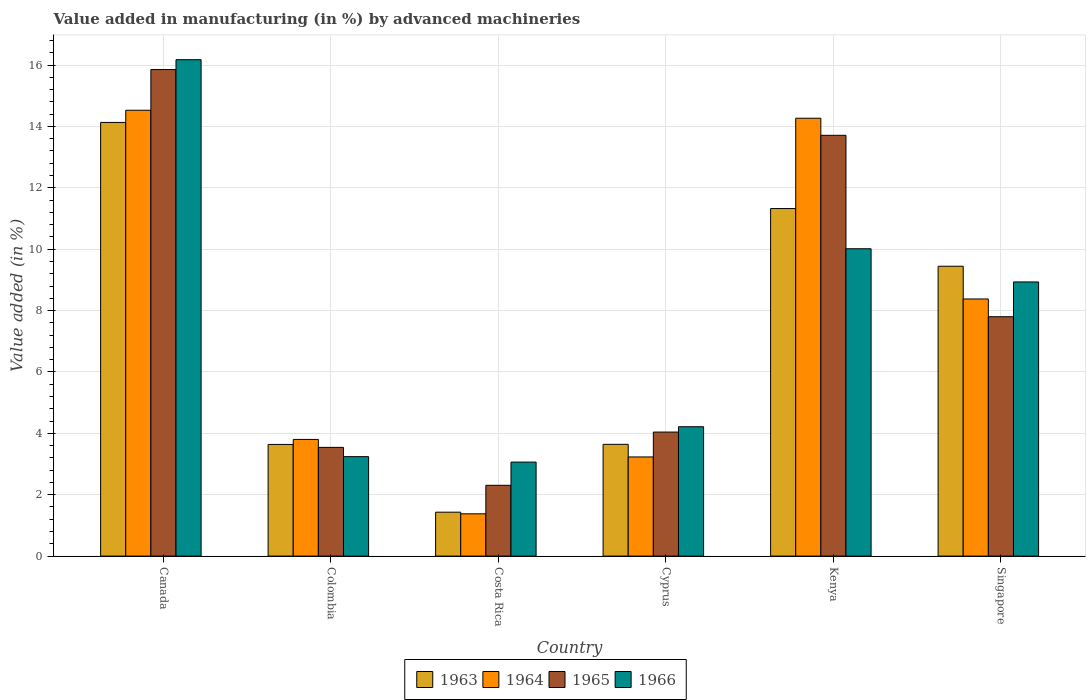How many groups of bars are there?
Your answer should be compact. 6. Are the number of bars per tick equal to the number of legend labels?
Offer a very short reply. Yes. How many bars are there on the 4th tick from the left?
Keep it short and to the point. 4. How many bars are there on the 3rd tick from the right?
Provide a short and direct response. 4. What is the percentage of value added in manufacturing by advanced machineries in 1963 in Colombia?
Your answer should be very brief. 3.64. Across all countries, what is the maximum percentage of value added in manufacturing by advanced machineries in 1965?
Provide a succinct answer. 15.85. Across all countries, what is the minimum percentage of value added in manufacturing by advanced machineries in 1966?
Your answer should be compact. 3.06. In which country was the percentage of value added in manufacturing by advanced machineries in 1964 maximum?
Your response must be concise. Canada. What is the total percentage of value added in manufacturing by advanced machineries in 1965 in the graph?
Give a very brief answer. 47.25. What is the difference between the percentage of value added in manufacturing by advanced machineries in 1963 in Colombia and that in Singapore?
Give a very brief answer. -5.81. What is the difference between the percentage of value added in manufacturing by advanced machineries in 1963 in Colombia and the percentage of value added in manufacturing by advanced machineries in 1966 in Costa Rica?
Your answer should be very brief. 0.57. What is the average percentage of value added in manufacturing by advanced machineries in 1966 per country?
Your answer should be compact. 7.61. What is the difference between the percentage of value added in manufacturing by advanced machineries of/in 1966 and percentage of value added in manufacturing by advanced machineries of/in 1965 in Singapore?
Ensure brevity in your answer.  1.13. In how many countries, is the percentage of value added in manufacturing by advanced machineries in 1963 greater than 6 %?
Provide a short and direct response. 3. What is the ratio of the percentage of value added in manufacturing by advanced machineries in 1964 in Canada to that in Cyprus?
Provide a short and direct response. 4.5. Is the difference between the percentage of value added in manufacturing by advanced machineries in 1966 in Canada and Costa Rica greater than the difference between the percentage of value added in manufacturing by advanced machineries in 1965 in Canada and Costa Rica?
Ensure brevity in your answer.  No. What is the difference between the highest and the second highest percentage of value added in manufacturing by advanced machineries in 1965?
Make the answer very short. -5.91. What is the difference between the highest and the lowest percentage of value added in manufacturing by advanced machineries in 1966?
Offer a very short reply. 13.11. In how many countries, is the percentage of value added in manufacturing by advanced machineries in 1963 greater than the average percentage of value added in manufacturing by advanced machineries in 1963 taken over all countries?
Provide a succinct answer. 3. Is the sum of the percentage of value added in manufacturing by advanced machineries in 1963 in Costa Rica and Kenya greater than the maximum percentage of value added in manufacturing by advanced machineries in 1966 across all countries?
Provide a short and direct response. No. What does the 3rd bar from the left in Cyprus represents?
Your response must be concise. 1965. How many bars are there?
Offer a terse response. 24. How many countries are there in the graph?
Provide a short and direct response. 6. Are the values on the major ticks of Y-axis written in scientific E-notation?
Provide a short and direct response. No. How many legend labels are there?
Make the answer very short. 4. How are the legend labels stacked?
Give a very brief answer. Horizontal. What is the title of the graph?
Make the answer very short. Value added in manufacturing (in %) by advanced machineries. Does "1989" appear as one of the legend labels in the graph?
Your answer should be very brief. No. What is the label or title of the X-axis?
Your response must be concise. Country. What is the label or title of the Y-axis?
Make the answer very short. Value added (in %). What is the Value added (in %) in 1963 in Canada?
Offer a very short reply. 14.13. What is the Value added (in %) in 1964 in Canada?
Your response must be concise. 14.53. What is the Value added (in %) of 1965 in Canada?
Make the answer very short. 15.85. What is the Value added (in %) in 1966 in Canada?
Offer a very short reply. 16.17. What is the Value added (in %) in 1963 in Colombia?
Your response must be concise. 3.64. What is the Value added (in %) of 1964 in Colombia?
Make the answer very short. 3.8. What is the Value added (in %) in 1965 in Colombia?
Give a very brief answer. 3.54. What is the Value added (in %) in 1966 in Colombia?
Offer a terse response. 3.24. What is the Value added (in %) of 1963 in Costa Rica?
Ensure brevity in your answer.  1.43. What is the Value added (in %) in 1964 in Costa Rica?
Give a very brief answer. 1.38. What is the Value added (in %) in 1965 in Costa Rica?
Offer a very short reply. 2.31. What is the Value added (in %) of 1966 in Costa Rica?
Keep it short and to the point. 3.06. What is the Value added (in %) of 1963 in Cyprus?
Offer a very short reply. 3.64. What is the Value added (in %) in 1964 in Cyprus?
Keep it short and to the point. 3.23. What is the Value added (in %) of 1965 in Cyprus?
Your answer should be very brief. 4.04. What is the Value added (in %) in 1966 in Cyprus?
Make the answer very short. 4.22. What is the Value added (in %) in 1963 in Kenya?
Provide a short and direct response. 11.32. What is the Value added (in %) of 1964 in Kenya?
Offer a very short reply. 14.27. What is the Value added (in %) of 1965 in Kenya?
Provide a succinct answer. 13.71. What is the Value added (in %) in 1966 in Kenya?
Ensure brevity in your answer.  10.01. What is the Value added (in %) in 1963 in Singapore?
Your response must be concise. 9.44. What is the Value added (in %) in 1964 in Singapore?
Give a very brief answer. 8.38. What is the Value added (in %) of 1965 in Singapore?
Offer a terse response. 7.8. What is the Value added (in %) in 1966 in Singapore?
Provide a succinct answer. 8.93. Across all countries, what is the maximum Value added (in %) in 1963?
Your answer should be very brief. 14.13. Across all countries, what is the maximum Value added (in %) of 1964?
Offer a terse response. 14.53. Across all countries, what is the maximum Value added (in %) in 1965?
Provide a succinct answer. 15.85. Across all countries, what is the maximum Value added (in %) in 1966?
Make the answer very short. 16.17. Across all countries, what is the minimum Value added (in %) in 1963?
Keep it short and to the point. 1.43. Across all countries, what is the minimum Value added (in %) of 1964?
Ensure brevity in your answer.  1.38. Across all countries, what is the minimum Value added (in %) of 1965?
Keep it short and to the point. 2.31. Across all countries, what is the minimum Value added (in %) of 1966?
Provide a short and direct response. 3.06. What is the total Value added (in %) in 1963 in the graph?
Make the answer very short. 43.61. What is the total Value added (in %) in 1964 in the graph?
Provide a short and direct response. 45.58. What is the total Value added (in %) in 1965 in the graph?
Keep it short and to the point. 47.25. What is the total Value added (in %) of 1966 in the graph?
Keep it short and to the point. 45.64. What is the difference between the Value added (in %) in 1963 in Canada and that in Colombia?
Keep it short and to the point. 10.49. What is the difference between the Value added (in %) in 1964 in Canada and that in Colombia?
Make the answer very short. 10.72. What is the difference between the Value added (in %) of 1965 in Canada and that in Colombia?
Keep it short and to the point. 12.31. What is the difference between the Value added (in %) in 1966 in Canada and that in Colombia?
Your response must be concise. 12.93. What is the difference between the Value added (in %) of 1963 in Canada and that in Costa Rica?
Offer a very short reply. 12.7. What is the difference between the Value added (in %) of 1964 in Canada and that in Costa Rica?
Give a very brief answer. 13.15. What is the difference between the Value added (in %) in 1965 in Canada and that in Costa Rica?
Provide a succinct answer. 13.55. What is the difference between the Value added (in %) in 1966 in Canada and that in Costa Rica?
Offer a terse response. 13.11. What is the difference between the Value added (in %) in 1963 in Canada and that in Cyprus?
Ensure brevity in your answer.  10.49. What is the difference between the Value added (in %) in 1964 in Canada and that in Cyprus?
Provide a succinct answer. 11.3. What is the difference between the Value added (in %) of 1965 in Canada and that in Cyprus?
Keep it short and to the point. 11.81. What is the difference between the Value added (in %) in 1966 in Canada and that in Cyprus?
Ensure brevity in your answer.  11.96. What is the difference between the Value added (in %) in 1963 in Canada and that in Kenya?
Provide a short and direct response. 2.81. What is the difference between the Value added (in %) of 1964 in Canada and that in Kenya?
Provide a succinct answer. 0.26. What is the difference between the Value added (in %) in 1965 in Canada and that in Kenya?
Your response must be concise. 2.14. What is the difference between the Value added (in %) in 1966 in Canada and that in Kenya?
Ensure brevity in your answer.  6.16. What is the difference between the Value added (in %) in 1963 in Canada and that in Singapore?
Your response must be concise. 4.69. What is the difference between the Value added (in %) in 1964 in Canada and that in Singapore?
Your answer should be compact. 6.15. What is the difference between the Value added (in %) of 1965 in Canada and that in Singapore?
Provide a succinct answer. 8.05. What is the difference between the Value added (in %) of 1966 in Canada and that in Singapore?
Offer a very short reply. 7.24. What is the difference between the Value added (in %) of 1963 in Colombia and that in Costa Rica?
Keep it short and to the point. 2.21. What is the difference between the Value added (in %) in 1964 in Colombia and that in Costa Rica?
Provide a succinct answer. 2.42. What is the difference between the Value added (in %) of 1965 in Colombia and that in Costa Rica?
Keep it short and to the point. 1.24. What is the difference between the Value added (in %) of 1966 in Colombia and that in Costa Rica?
Offer a very short reply. 0.18. What is the difference between the Value added (in %) of 1963 in Colombia and that in Cyprus?
Keep it short and to the point. -0. What is the difference between the Value added (in %) in 1964 in Colombia and that in Cyprus?
Keep it short and to the point. 0.57. What is the difference between the Value added (in %) in 1965 in Colombia and that in Cyprus?
Your answer should be very brief. -0.5. What is the difference between the Value added (in %) of 1966 in Colombia and that in Cyprus?
Your answer should be compact. -0.97. What is the difference between the Value added (in %) of 1963 in Colombia and that in Kenya?
Keep it short and to the point. -7.69. What is the difference between the Value added (in %) in 1964 in Colombia and that in Kenya?
Make the answer very short. -10.47. What is the difference between the Value added (in %) of 1965 in Colombia and that in Kenya?
Offer a very short reply. -10.17. What is the difference between the Value added (in %) in 1966 in Colombia and that in Kenya?
Provide a succinct answer. -6.77. What is the difference between the Value added (in %) of 1963 in Colombia and that in Singapore?
Make the answer very short. -5.81. What is the difference between the Value added (in %) of 1964 in Colombia and that in Singapore?
Make the answer very short. -4.58. What is the difference between the Value added (in %) in 1965 in Colombia and that in Singapore?
Your response must be concise. -4.26. What is the difference between the Value added (in %) in 1966 in Colombia and that in Singapore?
Give a very brief answer. -5.69. What is the difference between the Value added (in %) of 1963 in Costa Rica and that in Cyprus?
Provide a short and direct response. -2.21. What is the difference between the Value added (in %) in 1964 in Costa Rica and that in Cyprus?
Give a very brief answer. -1.85. What is the difference between the Value added (in %) in 1965 in Costa Rica and that in Cyprus?
Keep it short and to the point. -1.73. What is the difference between the Value added (in %) of 1966 in Costa Rica and that in Cyprus?
Your answer should be compact. -1.15. What is the difference between the Value added (in %) of 1963 in Costa Rica and that in Kenya?
Your answer should be compact. -9.89. What is the difference between the Value added (in %) of 1964 in Costa Rica and that in Kenya?
Keep it short and to the point. -12.89. What is the difference between the Value added (in %) of 1965 in Costa Rica and that in Kenya?
Your response must be concise. -11.4. What is the difference between the Value added (in %) of 1966 in Costa Rica and that in Kenya?
Make the answer very short. -6.95. What is the difference between the Value added (in %) of 1963 in Costa Rica and that in Singapore?
Give a very brief answer. -8.01. What is the difference between the Value added (in %) of 1964 in Costa Rica and that in Singapore?
Your response must be concise. -7. What is the difference between the Value added (in %) in 1965 in Costa Rica and that in Singapore?
Make the answer very short. -5.49. What is the difference between the Value added (in %) in 1966 in Costa Rica and that in Singapore?
Make the answer very short. -5.87. What is the difference between the Value added (in %) of 1963 in Cyprus and that in Kenya?
Your answer should be very brief. -7.68. What is the difference between the Value added (in %) in 1964 in Cyprus and that in Kenya?
Give a very brief answer. -11.04. What is the difference between the Value added (in %) of 1965 in Cyprus and that in Kenya?
Your response must be concise. -9.67. What is the difference between the Value added (in %) in 1966 in Cyprus and that in Kenya?
Offer a terse response. -5.8. What is the difference between the Value added (in %) in 1963 in Cyprus and that in Singapore?
Make the answer very short. -5.8. What is the difference between the Value added (in %) in 1964 in Cyprus and that in Singapore?
Keep it short and to the point. -5.15. What is the difference between the Value added (in %) of 1965 in Cyprus and that in Singapore?
Your response must be concise. -3.76. What is the difference between the Value added (in %) of 1966 in Cyprus and that in Singapore?
Your response must be concise. -4.72. What is the difference between the Value added (in %) of 1963 in Kenya and that in Singapore?
Your response must be concise. 1.88. What is the difference between the Value added (in %) in 1964 in Kenya and that in Singapore?
Give a very brief answer. 5.89. What is the difference between the Value added (in %) of 1965 in Kenya and that in Singapore?
Your answer should be compact. 5.91. What is the difference between the Value added (in %) in 1966 in Kenya and that in Singapore?
Provide a short and direct response. 1.08. What is the difference between the Value added (in %) of 1963 in Canada and the Value added (in %) of 1964 in Colombia?
Your answer should be very brief. 10.33. What is the difference between the Value added (in %) of 1963 in Canada and the Value added (in %) of 1965 in Colombia?
Give a very brief answer. 10.59. What is the difference between the Value added (in %) of 1963 in Canada and the Value added (in %) of 1966 in Colombia?
Offer a very short reply. 10.89. What is the difference between the Value added (in %) of 1964 in Canada and the Value added (in %) of 1965 in Colombia?
Your answer should be compact. 10.98. What is the difference between the Value added (in %) in 1964 in Canada and the Value added (in %) in 1966 in Colombia?
Ensure brevity in your answer.  11.29. What is the difference between the Value added (in %) of 1965 in Canada and the Value added (in %) of 1966 in Colombia?
Offer a very short reply. 12.61. What is the difference between the Value added (in %) in 1963 in Canada and the Value added (in %) in 1964 in Costa Rica?
Provide a succinct answer. 12.75. What is the difference between the Value added (in %) of 1963 in Canada and the Value added (in %) of 1965 in Costa Rica?
Provide a short and direct response. 11.82. What is the difference between the Value added (in %) in 1963 in Canada and the Value added (in %) in 1966 in Costa Rica?
Your answer should be compact. 11.07. What is the difference between the Value added (in %) in 1964 in Canada and the Value added (in %) in 1965 in Costa Rica?
Your response must be concise. 12.22. What is the difference between the Value added (in %) of 1964 in Canada and the Value added (in %) of 1966 in Costa Rica?
Provide a short and direct response. 11.46. What is the difference between the Value added (in %) of 1965 in Canada and the Value added (in %) of 1966 in Costa Rica?
Provide a succinct answer. 12.79. What is the difference between the Value added (in %) in 1963 in Canada and the Value added (in %) in 1964 in Cyprus?
Make the answer very short. 10.9. What is the difference between the Value added (in %) in 1963 in Canada and the Value added (in %) in 1965 in Cyprus?
Keep it short and to the point. 10.09. What is the difference between the Value added (in %) in 1963 in Canada and the Value added (in %) in 1966 in Cyprus?
Ensure brevity in your answer.  9.92. What is the difference between the Value added (in %) in 1964 in Canada and the Value added (in %) in 1965 in Cyprus?
Give a very brief answer. 10.49. What is the difference between the Value added (in %) in 1964 in Canada and the Value added (in %) in 1966 in Cyprus?
Provide a succinct answer. 10.31. What is the difference between the Value added (in %) in 1965 in Canada and the Value added (in %) in 1966 in Cyprus?
Your answer should be compact. 11.64. What is the difference between the Value added (in %) in 1963 in Canada and the Value added (in %) in 1964 in Kenya?
Provide a short and direct response. -0.14. What is the difference between the Value added (in %) of 1963 in Canada and the Value added (in %) of 1965 in Kenya?
Give a very brief answer. 0.42. What is the difference between the Value added (in %) in 1963 in Canada and the Value added (in %) in 1966 in Kenya?
Provide a short and direct response. 4.12. What is the difference between the Value added (in %) of 1964 in Canada and the Value added (in %) of 1965 in Kenya?
Provide a succinct answer. 0.82. What is the difference between the Value added (in %) of 1964 in Canada and the Value added (in %) of 1966 in Kenya?
Your response must be concise. 4.51. What is the difference between the Value added (in %) in 1965 in Canada and the Value added (in %) in 1966 in Kenya?
Ensure brevity in your answer.  5.84. What is the difference between the Value added (in %) of 1963 in Canada and the Value added (in %) of 1964 in Singapore?
Make the answer very short. 5.75. What is the difference between the Value added (in %) in 1963 in Canada and the Value added (in %) in 1965 in Singapore?
Make the answer very short. 6.33. What is the difference between the Value added (in %) in 1963 in Canada and the Value added (in %) in 1966 in Singapore?
Your answer should be very brief. 5.2. What is the difference between the Value added (in %) in 1964 in Canada and the Value added (in %) in 1965 in Singapore?
Ensure brevity in your answer.  6.73. What is the difference between the Value added (in %) of 1964 in Canada and the Value added (in %) of 1966 in Singapore?
Give a very brief answer. 5.59. What is the difference between the Value added (in %) of 1965 in Canada and the Value added (in %) of 1966 in Singapore?
Offer a very short reply. 6.92. What is the difference between the Value added (in %) in 1963 in Colombia and the Value added (in %) in 1964 in Costa Rica?
Your answer should be very brief. 2.26. What is the difference between the Value added (in %) in 1963 in Colombia and the Value added (in %) in 1965 in Costa Rica?
Your answer should be very brief. 1.33. What is the difference between the Value added (in %) in 1963 in Colombia and the Value added (in %) in 1966 in Costa Rica?
Offer a very short reply. 0.57. What is the difference between the Value added (in %) in 1964 in Colombia and the Value added (in %) in 1965 in Costa Rica?
Provide a succinct answer. 1.49. What is the difference between the Value added (in %) of 1964 in Colombia and the Value added (in %) of 1966 in Costa Rica?
Offer a terse response. 0.74. What is the difference between the Value added (in %) of 1965 in Colombia and the Value added (in %) of 1966 in Costa Rica?
Provide a succinct answer. 0.48. What is the difference between the Value added (in %) of 1963 in Colombia and the Value added (in %) of 1964 in Cyprus?
Provide a succinct answer. 0.41. What is the difference between the Value added (in %) of 1963 in Colombia and the Value added (in %) of 1965 in Cyprus?
Provide a short and direct response. -0.4. What is the difference between the Value added (in %) in 1963 in Colombia and the Value added (in %) in 1966 in Cyprus?
Keep it short and to the point. -0.58. What is the difference between the Value added (in %) of 1964 in Colombia and the Value added (in %) of 1965 in Cyprus?
Provide a short and direct response. -0.24. What is the difference between the Value added (in %) of 1964 in Colombia and the Value added (in %) of 1966 in Cyprus?
Your response must be concise. -0.41. What is the difference between the Value added (in %) in 1965 in Colombia and the Value added (in %) in 1966 in Cyprus?
Keep it short and to the point. -0.67. What is the difference between the Value added (in %) in 1963 in Colombia and the Value added (in %) in 1964 in Kenya?
Ensure brevity in your answer.  -10.63. What is the difference between the Value added (in %) in 1963 in Colombia and the Value added (in %) in 1965 in Kenya?
Offer a very short reply. -10.07. What is the difference between the Value added (in %) in 1963 in Colombia and the Value added (in %) in 1966 in Kenya?
Ensure brevity in your answer.  -6.38. What is the difference between the Value added (in %) of 1964 in Colombia and the Value added (in %) of 1965 in Kenya?
Your answer should be very brief. -9.91. What is the difference between the Value added (in %) of 1964 in Colombia and the Value added (in %) of 1966 in Kenya?
Provide a short and direct response. -6.21. What is the difference between the Value added (in %) in 1965 in Colombia and the Value added (in %) in 1966 in Kenya?
Your response must be concise. -6.47. What is the difference between the Value added (in %) of 1963 in Colombia and the Value added (in %) of 1964 in Singapore?
Provide a succinct answer. -4.74. What is the difference between the Value added (in %) of 1963 in Colombia and the Value added (in %) of 1965 in Singapore?
Offer a very short reply. -4.16. What is the difference between the Value added (in %) in 1963 in Colombia and the Value added (in %) in 1966 in Singapore?
Give a very brief answer. -5.29. What is the difference between the Value added (in %) of 1964 in Colombia and the Value added (in %) of 1965 in Singapore?
Your answer should be very brief. -4. What is the difference between the Value added (in %) in 1964 in Colombia and the Value added (in %) in 1966 in Singapore?
Your response must be concise. -5.13. What is the difference between the Value added (in %) in 1965 in Colombia and the Value added (in %) in 1966 in Singapore?
Offer a terse response. -5.39. What is the difference between the Value added (in %) of 1963 in Costa Rica and the Value added (in %) of 1964 in Cyprus?
Ensure brevity in your answer.  -1.8. What is the difference between the Value added (in %) in 1963 in Costa Rica and the Value added (in %) in 1965 in Cyprus?
Offer a terse response. -2.61. What is the difference between the Value added (in %) of 1963 in Costa Rica and the Value added (in %) of 1966 in Cyprus?
Your answer should be compact. -2.78. What is the difference between the Value added (in %) in 1964 in Costa Rica and the Value added (in %) in 1965 in Cyprus?
Give a very brief answer. -2.66. What is the difference between the Value added (in %) of 1964 in Costa Rica and the Value added (in %) of 1966 in Cyprus?
Make the answer very short. -2.84. What is the difference between the Value added (in %) of 1965 in Costa Rica and the Value added (in %) of 1966 in Cyprus?
Provide a succinct answer. -1.91. What is the difference between the Value added (in %) in 1963 in Costa Rica and the Value added (in %) in 1964 in Kenya?
Make the answer very short. -12.84. What is the difference between the Value added (in %) in 1963 in Costa Rica and the Value added (in %) in 1965 in Kenya?
Provide a succinct answer. -12.28. What is the difference between the Value added (in %) in 1963 in Costa Rica and the Value added (in %) in 1966 in Kenya?
Your answer should be compact. -8.58. What is the difference between the Value added (in %) in 1964 in Costa Rica and the Value added (in %) in 1965 in Kenya?
Offer a terse response. -12.33. What is the difference between the Value added (in %) of 1964 in Costa Rica and the Value added (in %) of 1966 in Kenya?
Your response must be concise. -8.64. What is the difference between the Value added (in %) of 1965 in Costa Rica and the Value added (in %) of 1966 in Kenya?
Your answer should be compact. -7.71. What is the difference between the Value added (in %) of 1963 in Costa Rica and the Value added (in %) of 1964 in Singapore?
Provide a short and direct response. -6.95. What is the difference between the Value added (in %) in 1963 in Costa Rica and the Value added (in %) in 1965 in Singapore?
Ensure brevity in your answer.  -6.37. What is the difference between the Value added (in %) of 1963 in Costa Rica and the Value added (in %) of 1966 in Singapore?
Your answer should be very brief. -7.5. What is the difference between the Value added (in %) in 1964 in Costa Rica and the Value added (in %) in 1965 in Singapore?
Give a very brief answer. -6.42. What is the difference between the Value added (in %) of 1964 in Costa Rica and the Value added (in %) of 1966 in Singapore?
Give a very brief answer. -7.55. What is the difference between the Value added (in %) in 1965 in Costa Rica and the Value added (in %) in 1966 in Singapore?
Ensure brevity in your answer.  -6.63. What is the difference between the Value added (in %) of 1963 in Cyprus and the Value added (in %) of 1964 in Kenya?
Offer a very short reply. -10.63. What is the difference between the Value added (in %) in 1963 in Cyprus and the Value added (in %) in 1965 in Kenya?
Offer a terse response. -10.07. What is the difference between the Value added (in %) of 1963 in Cyprus and the Value added (in %) of 1966 in Kenya?
Your answer should be very brief. -6.37. What is the difference between the Value added (in %) of 1964 in Cyprus and the Value added (in %) of 1965 in Kenya?
Your answer should be very brief. -10.48. What is the difference between the Value added (in %) of 1964 in Cyprus and the Value added (in %) of 1966 in Kenya?
Ensure brevity in your answer.  -6.78. What is the difference between the Value added (in %) of 1965 in Cyprus and the Value added (in %) of 1966 in Kenya?
Your answer should be compact. -5.97. What is the difference between the Value added (in %) of 1963 in Cyprus and the Value added (in %) of 1964 in Singapore?
Keep it short and to the point. -4.74. What is the difference between the Value added (in %) in 1963 in Cyprus and the Value added (in %) in 1965 in Singapore?
Provide a short and direct response. -4.16. What is the difference between the Value added (in %) in 1963 in Cyprus and the Value added (in %) in 1966 in Singapore?
Make the answer very short. -5.29. What is the difference between the Value added (in %) in 1964 in Cyprus and the Value added (in %) in 1965 in Singapore?
Provide a succinct answer. -4.57. What is the difference between the Value added (in %) of 1964 in Cyprus and the Value added (in %) of 1966 in Singapore?
Provide a succinct answer. -5.7. What is the difference between the Value added (in %) of 1965 in Cyprus and the Value added (in %) of 1966 in Singapore?
Make the answer very short. -4.89. What is the difference between the Value added (in %) in 1963 in Kenya and the Value added (in %) in 1964 in Singapore?
Your answer should be compact. 2.95. What is the difference between the Value added (in %) of 1963 in Kenya and the Value added (in %) of 1965 in Singapore?
Your answer should be very brief. 3.52. What is the difference between the Value added (in %) of 1963 in Kenya and the Value added (in %) of 1966 in Singapore?
Your answer should be compact. 2.39. What is the difference between the Value added (in %) of 1964 in Kenya and the Value added (in %) of 1965 in Singapore?
Provide a short and direct response. 6.47. What is the difference between the Value added (in %) in 1964 in Kenya and the Value added (in %) in 1966 in Singapore?
Keep it short and to the point. 5.33. What is the difference between the Value added (in %) in 1965 in Kenya and the Value added (in %) in 1966 in Singapore?
Keep it short and to the point. 4.78. What is the average Value added (in %) in 1963 per country?
Provide a short and direct response. 7.27. What is the average Value added (in %) in 1964 per country?
Offer a terse response. 7.6. What is the average Value added (in %) of 1965 per country?
Make the answer very short. 7.88. What is the average Value added (in %) of 1966 per country?
Provide a succinct answer. 7.61. What is the difference between the Value added (in %) of 1963 and Value added (in %) of 1964 in Canada?
Provide a short and direct response. -0.4. What is the difference between the Value added (in %) of 1963 and Value added (in %) of 1965 in Canada?
Ensure brevity in your answer.  -1.72. What is the difference between the Value added (in %) in 1963 and Value added (in %) in 1966 in Canada?
Provide a short and direct response. -2.04. What is the difference between the Value added (in %) in 1964 and Value added (in %) in 1965 in Canada?
Offer a terse response. -1.33. What is the difference between the Value added (in %) of 1964 and Value added (in %) of 1966 in Canada?
Provide a succinct answer. -1.65. What is the difference between the Value added (in %) in 1965 and Value added (in %) in 1966 in Canada?
Give a very brief answer. -0.32. What is the difference between the Value added (in %) in 1963 and Value added (in %) in 1964 in Colombia?
Give a very brief answer. -0.16. What is the difference between the Value added (in %) of 1963 and Value added (in %) of 1965 in Colombia?
Your response must be concise. 0.1. What is the difference between the Value added (in %) of 1963 and Value added (in %) of 1966 in Colombia?
Ensure brevity in your answer.  0.4. What is the difference between the Value added (in %) in 1964 and Value added (in %) in 1965 in Colombia?
Ensure brevity in your answer.  0.26. What is the difference between the Value added (in %) in 1964 and Value added (in %) in 1966 in Colombia?
Your answer should be very brief. 0.56. What is the difference between the Value added (in %) in 1965 and Value added (in %) in 1966 in Colombia?
Your answer should be very brief. 0.3. What is the difference between the Value added (in %) of 1963 and Value added (in %) of 1964 in Costa Rica?
Give a very brief answer. 0.05. What is the difference between the Value added (in %) in 1963 and Value added (in %) in 1965 in Costa Rica?
Your response must be concise. -0.88. What is the difference between the Value added (in %) in 1963 and Value added (in %) in 1966 in Costa Rica?
Ensure brevity in your answer.  -1.63. What is the difference between the Value added (in %) of 1964 and Value added (in %) of 1965 in Costa Rica?
Your response must be concise. -0.93. What is the difference between the Value added (in %) of 1964 and Value added (in %) of 1966 in Costa Rica?
Keep it short and to the point. -1.69. What is the difference between the Value added (in %) in 1965 and Value added (in %) in 1966 in Costa Rica?
Keep it short and to the point. -0.76. What is the difference between the Value added (in %) of 1963 and Value added (in %) of 1964 in Cyprus?
Give a very brief answer. 0.41. What is the difference between the Value added (in %) in 1963 and Value added (in %) in 1965 in Cyprus?
Provide a succinct answer. -0.4. What is the difference between the Value added (in %) in 1963 and Value added (in %) in 1966 in Cyprus?
Keep it short and to the point. -0.57. What is the difference between the Value added (in %) in 1964 and Value added (in %) in 1965 in Cyprus?
Your response must be concise. -0.81. What is the difference between the Value added (in %) of 1964 and Value added (in %) of 1966 in Cyprus?
Your answer should be compact. -0.98. What is the difference between the Value added (in %) in 1965 and Value added (in %) in 1966 in Cyprus?
Make the answer very short. -0.17. What is the difference between the Value added (in %) in 1963 and Value added (in %) in 1964 in Kenya?
Keep it short and to the point. -2.94. What is the difference between the Value added (in %) of 1963 and Value added (in %) of 1965 in Kenya?
Provide a short and direct response. -2.39. What is the difference between the Value added (in %) in 1963 and Value added (in %) in 1966 in Kenya?
Offer a terse response. 1.31. What is the difference between the Value added (in %) of 1964 and Value added (in %) of 1965 in Kenya?
Offer a very short reply. 0.56. What is the difference between the Value added (in %) in 1964 and Value added (in %) in 1966 in Kenya?
Provide a short and direct response. 4.25. What is the difference between the Value added (in %) of 1965 and Value added (in %) of 1966 in Kenya?
Your answer should be very brief. 3.7. What is the difference between the Value added (in %) of 1963 and Value added (in %) of 1964 in Singapore?
Provide a short and direct response. 1.07. What is the difference between the Value added (in %) of 1963 and Value added (in %) of 1965 in Singapore?
Your response must be concise. 1.64. What is the difference between the Value added (in %) of 1963 and Value added (in %) of 1966 in Singapore?
Your answer should be very brief. 0.51. What is the difference between the Value added (in %) in 1964 and Value added (in %) in 1965 in Singapore?
Keep it short and to the point. 0.58. What is the difference between the Value added (in %) of 1964 and Value added (in %) of 1966 in Singapore?
Ensure brevity in your answer.  -0.55. What is the difference between the Value added (in %) of 1965 and Value added (in %) of 1966 in Singapore?
Offer a terse response. -1.13. What is the ratio of the Value added (in %) in 1963 in Canada to that in Colombia?
Keep it short and to the point. 3.88. What is the ratio of the Value added (in %) in 1964 in Canada to that in Colombia?
Your answer should be very brief. 3.82. What is the ratio of the Value added (in %) in 1965 in Canada to that in Colombia?
Make the answer very short. 4.48. What is the ratio of the Value added (in %) in 1966 in Canada to that in Colombia?
Provide a succinct answer. 4.99. What is the ratio of the Value added (in %) in 1963 in Canada to that in Costa Rica?
Offer a very short reply. 9.87. What is the ratio of the Value added (in %) in 1964 in Canada to that in Costa Rica?
Your response must be concise. 10.54. What is the ratio of the Value added (in %) in 1965 in Canada to that in Costa Rica?
Your answer should be very brief. 6.87. What is the ratio of the Value added (in %) of 1966 in Canada to that in Costa Rica?
Your answer should be very brief. 5.28. What is the ratio of the Value added (in %) of 1963 in Canada to that in Cyprus?
Your response must be concise. 3.88. What is the ratio of the Value added (in %) in 1964 in Canada to that in Cyprus?
Provide a short and direct response. 4.5. What is the ratio of the Value added (in %) of 1965 in Canada to that in Cyprus?
Your answer should be very brief. 3.92. What is the ratio of the Value added (in %) in 1966 in Canada to that in Cyprus?
Offer a terse response. 3.84. What is the ratio of the Value added (in %) in 1963 in Canada to that in Kenya?
Make the answer very short. 1.25. What is the ratio of the Value added (in %) of 1964 in Canada to that in Kenya?
Give a very brief answer. 1.02. What is the ratio of the Value added (in %) of 1965 in Canada to that in Kenya?
Give a very brief answer. 1.16. What is the ratio of the Value added (in %) in 1966 in Canada to that in Kenya?
Provide a succinct answer. 1.62. What is the ratio of the Value added (in %) in 1963 in Canada to that in Singapore?
Provide a short and direct response. 1.5. What is the ratio of the Value added (in %) in 1964 in Canada to that in Singapore?
Keep it short and to the point. 1.73. What is the ratio of the Value added (in %) of 1965 in Canada to that in Singapore?
Your answer should be very brief. 2.03. What is the ratio of the Value added (in %) of 1966 in Canada to that in Singapore?
Keep it short and to the point. 1.81. What is the ratio of the Value added (in %) of 1963 in Colombia to that in Costa Rica?
Keep it short and to the point. 2.54. What is the ratio of the Value added (in %) in 1964 in Colombia to that in Costa Rica?
Provide a succinct answer. 2.76. What is the ratio of the Value added (in %) in 1965 in Colombia to that in Costa Rica?
Your answer should be compact. 1.54. What is the ratio of the Value added (in %) of 1966 in Colombia to that in Costa Rica?
Offer a very short reply. 1.06. What is the ratio of the Value added (in %) in 1964 in Colombia to that in Cyprus?
Give a very brief answer. 1.18. What is the ratio of the Value added (in %) of 1965 in Colombia to that in Cyprus?
Offer a very short reply. 0.88. What is the ratio of the Value added (in %) of 1966 in Colombia to that in Cyprus?
Your response must be concise. 0.77. What is the ratio of the Value added (in %) of 1963 in Colombia to that in Kenya?
Provide a succinct answer. 0.32. What is the ratio of the Value added (in %) of 1964 in Colombia to that in Kenya?
Provide a short and direct response. 0.27. What is the ratio of the Value added (in %) in 1965 in Colombia to that in Kenya?
Your answer should be very brief. 0.26. What is the ratio of the Value added (in %) in 1966 in Colombia to that in Kenya?
Give a very brief answer. 0.32. What is the ratio of the Value added (in %) of 1963 in Colombia to that in Singapore?
Your response must be concise. 0.39. What is the ratio of the Value added (in %) in 1964 in Colombia to that in Singapore?
Offer a very short reply. 0.45. What is the ratio of the Value added (in %) in 1965 in Colombia to that in Singapore?
Offer a terse response. 0.45. What is the ratio of the Value added (in %) of 1966 in Colombia to that in Singapore?
Provide a short and direct response. 0.36. What is the ratio of the Value added (in %) of 1963 in Costa Rica to that in Cyprus?
Your response must be concise. 0.39. What is the ratio of the Value added (in %) of 1964 in Costa Rica to that in Cyprus?
Your answer should be compact. 0.43. What is the ratio of the Value added (in %) in 1965 in Costa Rica to that in Cyprus?
Offer a terse response. 0.57. What is the ratio of the Value added (in %) in 1966 in Costa Rica to that in Cyprus?
Your answer should be very brief. 0.73. What is the ratio of the Value added (in %) in 1963 in Costa Rica to that in Kenya?
Ensure brevity in your answer.  0.13. What is the ratio of the Value added (in %) of 1964 in Costa Rica to that in Kenya?
Provide a succinct answer. 0.1. What is the ratio of the Value added (in %) of 1965 in Costa Rica to that in Kenya?
Your answer should be compact. 0.17. What is the ratio of the Value added (in %) of 1966 in Costa Rica to that in Kenya?
Provide a short and direct response. 0.31. What is the ratio of the Value added (in %) in 1963 in Costa Rica to that in Singapore?
Ensure brevity in your answer.  0.15. What is the ratio of the Value added (in %) in 1964 in Costa Rica to that in Singapore?
Your answer should be very brief. 0.16. What is the ratio of the Value added (in %) of 1965 in Costa Rica to that in Singapore?
Ensure brevity in your answer.  0.3. What is the ratio of the Value added (in %) of 1966 in Costa Rica to that in Singapore?
Provide a succinct answer. 0.34. What is the ratio of the Value added (in %) of 1963 in Cyprus to that in Kenya?
Your response must be concise. 0.32. What is the ratio of the Value added (in %) of 1964 in Cyprus to that in Kenya?
Your answer should be compact. 0.23. What is the ratio of the Value added (in %) in 1965 in Cyprus to that in Kenya?
Your answer should be very brief. 0.29. What is the ratio of the Value added (in %) in 1966 in Cyprus to that in Kenya?
Your answer should be very brief. 0.42. What is the ratio of the Value added (in %) in 1963 in Cyprus to that in Singapore?
Your response must be concise. 0.39. What is the ratio of the Value added (in %) of 1964 in Cyprus to that in Singapore?
Offer a terse response. 0.39. What is the ratio of the Value added (in %) of 1965 in Cyprus to that in Singapore?
Make the answer very short. 0.52. What is the ratio of the Value added (in %) of 1966 in Cyprus to that in Singapore?
Your response must be concise. 0.47. What is the ratio of the Value added (in %) in 1963 in Kenya to that in Singapore?
Provide a succinct answer. 1.2. What is the ratio of the Value added (in %) in 1964 in Kenya to that in Singapore?
Provide a short and direct response. 1.7. What is the ratio of the Value added (in %) of 1965 in Kenya to that in Singapore?
Offer a very short reply. 1.76. What is the ratio of the Value added (in %) in 1966 in Kenya to that in Singapore?
Make the answer very short. 1.12. What is the difference between the highest and the second highest Value added (in %) in 1963?
Provide a short and direct response. 2.81. What is the difference between the highest and the second highest Value added (in %) in 1964?
Your response must be concise. 0.26. What is the difference between the highest and the second highest Value added (in %) in 1965?
Make the answer very short. 2.14. What is the difference between the highest and the second highest Value added (in %) of 1966?
Give a very brief answer. 6.16. What is the difference between the highest and the lowest Value added (in %) in 1963?
Provide a succinct answer. 12.7. What is the difference between the highest and the lowest Value added (in %) of 1964?
Make the answer very short. 13.15. What is the difference between the highest and the lowest Value added (in %) of 1965?
Keep it short and to the point. 13.55. What is the difference between the highest and the lowest Value added (in %) of 1966?
Your answer should be compact. 13.11. 